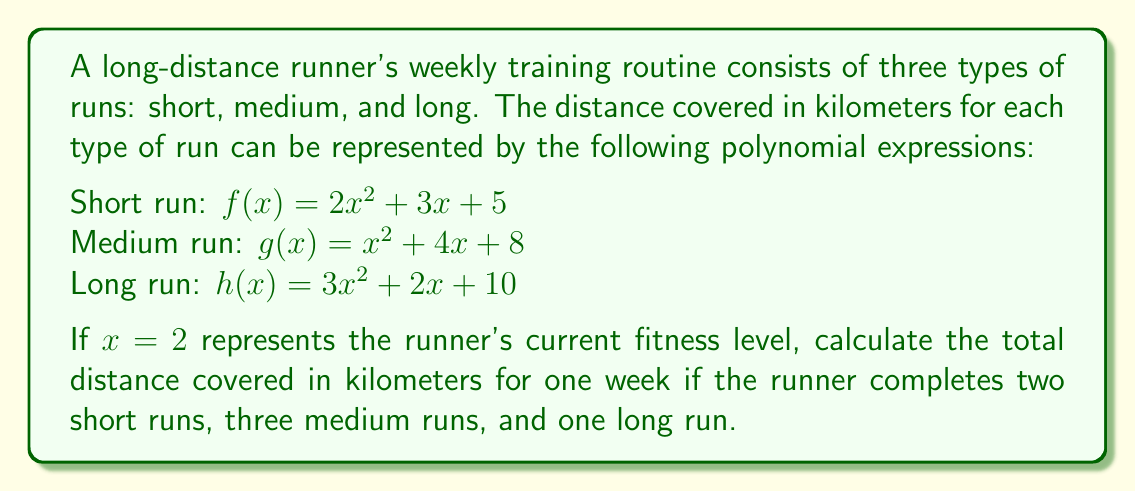Could you help me with this problem? Let's break this down step-by-step:

1) First, we need to calculate the distance for each type of run when $x = 2$:

   Short run: $f(2) = 2(2^2) + 3(2) + 5 = 2(4) + 6 + 5 = 8 + 6 + 5 = 19$ km

   Medium run: $g(2) = (2^2) + 4(2) + 8 = 4 + 8 + 8 = 20$ km

   Long run: $h(2) = 3(2^2) + 2(2) + 10 = 3(4) + 4 + 10 = 12 + 4 + 10 = 26$ km

2) Now, we need to multiply each distance by the number of times it's run in a week:

   Short runs: $19 \times 2 = 38$ km
   Medium runs: $20 \times 3 = 60$ km
   Long run: $26 \times 1 = 26$ km

3) Finally, we sum up all the distances:

   Total distance = Short runs + Medium runs + Long run
                  = $38 + 60 + 26 = 124$ km

Therefore, the total distance covered in one week is 124 kilometers.
Answer: 124 km 